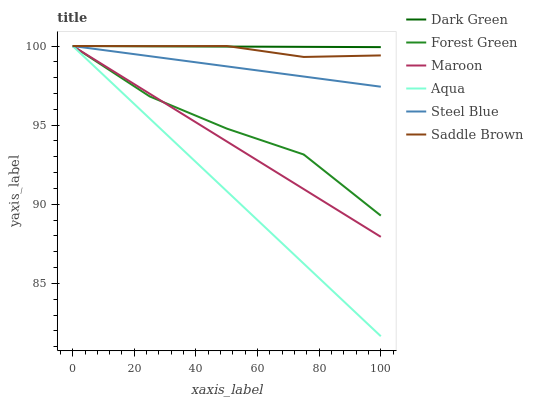Does Aqua have the minimum area under the curve?
Answer yes or no. Yes. Does Dark Green have the maximum area under the curve?
Answer yes or no. Yes. Does Steel Blue have the minimum area under the curve?
Answer yes or no. No. Does Steel Blue have the maximum area under the curve?
Answer yes or no. No. Is Aqua the smoothest?
Answer yes or no. Yes. Is Forest Green the roughest?
Answer yes or no. Yes. Is Steel Blue the smoothest?
Answer yes or no. No. Is Steel Blue the roughest?
Answer yes or no. No. Does Aqua have the lowest value?
Answer yes or no. Yes. Does Steel Blue have the lowest value?
Answer yes or no. No. Does Dark Green have the highest value?
Answer yes or no. Yes. Does Maroon intersect Steel Blue?
Answer yes or no. Yes. Is Maroon less than Steel Blue?
Answer yes or no. No. Is Maroon greater than Steel Blue?
Answer yes or no. No. 